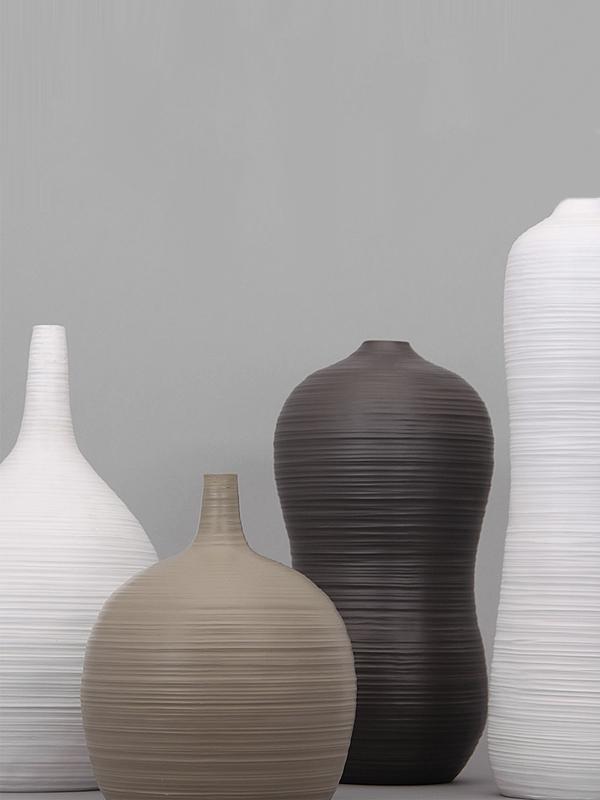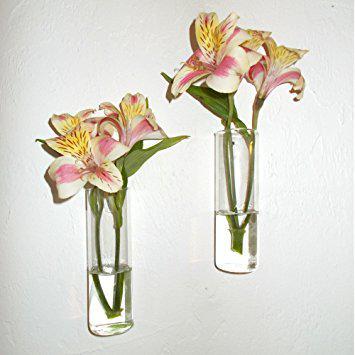The first image is the image on the left, the second image is the image on the right. Examine the images to the left and right. Is the description "In one of the image there is a black vase with a flower sticking out." accurate? Answer yes or no. No. The first image is the image on the left, the second image is the image on the right. Evaluate the accuracy of this statement regarding the images: "One vase is the exact size and shape as another one of the vases.". Is it true? Answer yes or no. Yes. 